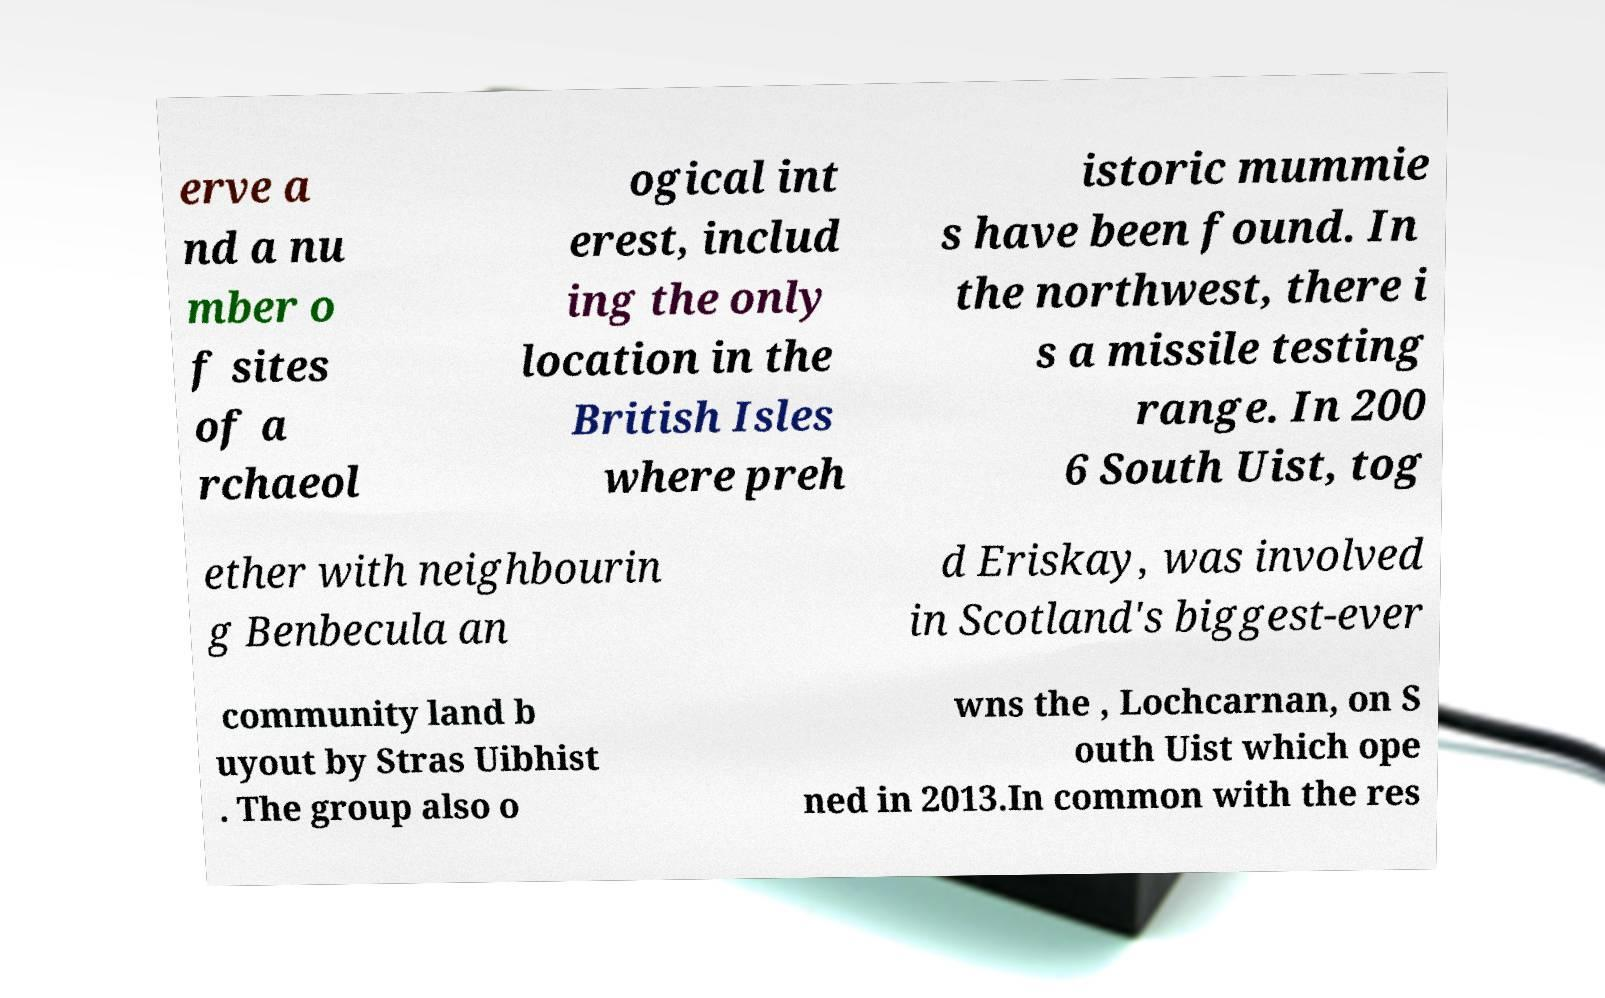Can you read and provide the text displayed in the image?This photo seems to have some interesting text. Can you extract and type it out for me? erve a nd a nu mber o f sites of a rchaeol ogical int erest, includ ing the only location in the British Isles where preh istoric mummie s have been found. In the northwest, there i s a missile testing range. In 200 6 South Uist, tog ether with neighbourin g Benbecula an d Eriskay, was involved in Scotland's biggest-ever community land b uyout by Stras Uibhist . The group also o wns the , Lochcarnan, on S outh Uist which ope ned in 2013.In common with the res 